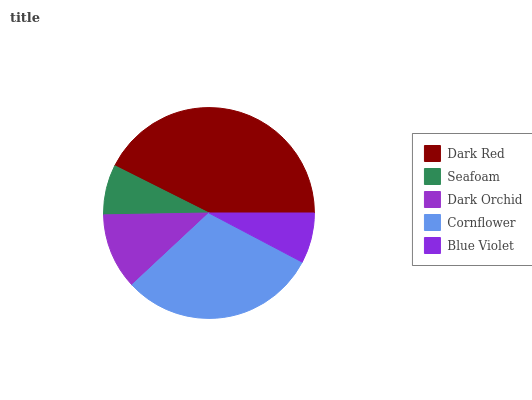Is Seafoam the minimum?
Answer yes or no. Yes. Is Dark Red the maximum?
Answer yes or no. Yes. Is Dark Orchid the minimum?
Answer yes or no. No. Is Dark Orchid the maximum?
Answer yes or no. No. Is Dark Orchid greater than Seafoam?
Answer yes or no. Yes. Is Seafoam less than Dark Orchid?
Answer yes or no. Yes. Is Seafoam greater than Dark Orchid?
Answer yes or no. No. Is Dark Orchid less than Seafoam?
Answer yes or no. No. Is Dark Orchid the high median?
Answer yes or no. Yes. Is Dark Orchid the low median?
Answer yes or no. Yes. Is Blue Violet the high median?
Answer yes or no. No. Is Dark Red the low median?
Answer yes or no. No. 